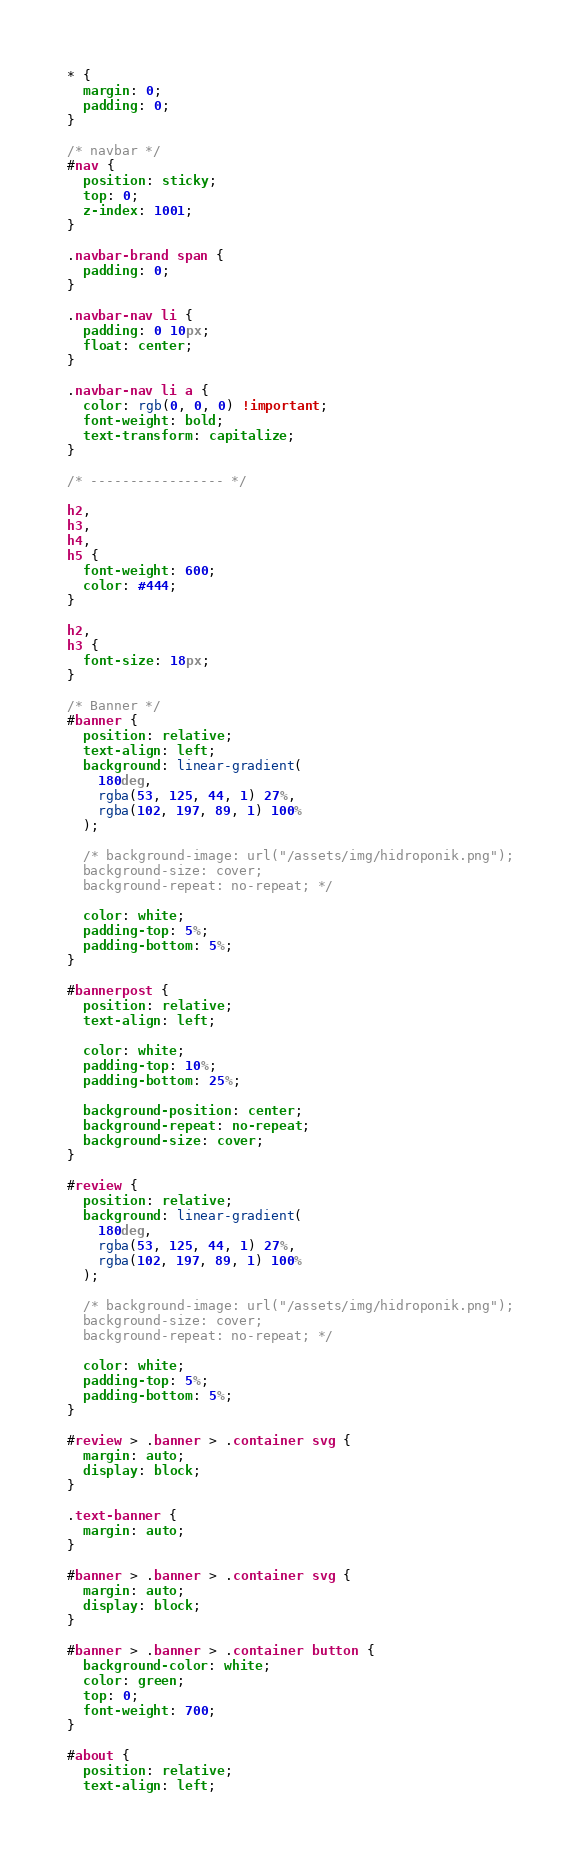<code> <loc_0><loc_0><loc_500><loc_500><_CSS_>* {
  margin: 0;
  padding: 0;
}

/* navbar */
#nav {
  position: sticky;
  top: 0;
  z-index: 1001;
}

.navbar-brand span {
  padding: 0;
}

.navbar-nav li {
  padding: 0 10px;
  float: center;
}

.navbar-nav li a {
  color: rgb(0, 0, 0) !important;
  font-weight: bold;
  text-transform: capitalize;
}

/* ----------------- */

h2,
h3,
h4,
h5 {
  font-weight: 600;
  color: #444;
}

h2,
h3 {
  font-size: 18px;
}

/* Banner */
#banner {
  position: relative;
  text-align: left;
  background: linear-gradient(
    180deg,
    rgba(53, 125, 44, 1) 27%,
    rgba(102, 197, 89, 1) 100%
  );

  /* background-image: url("/assets/img/hidroponik.png");
  background-size: cover;
  background-repeat: no-repeat; */

  color: white;
  padding-top: 5%;
  padding-bottom: 5%;
}

#bannerpost {
  position: relative;
  text-align: left;

  color: white;
  padding-top: 10%;
  padding-bottom: 25%;

  background-position: center;
  background-repeat: no-repeat;
  background-size: cover;
}

#review {
  position: relative;
  background: linear-gradient(
    180deg,
    rgba(53, 125, 44, 1) 27%,
    rgba(102, 197, 89, 1) 100%
  );

  /* background-image: url("/assets/img/hidroponik.png");
  background-size: cover;
  background-repeat: no-repeat; */

  color: white;
  padding-top: 5%;
  padding-bottom: 5%;
}

#review > .banner > .container svg {
  margin: auto;
  display: block;
}

.text-banner {
  margin: auto;
}

#banner > .banner > .container svg {
  margin: auto;
  display: block;
}

#banner > .banner > .container button {
  background-color: white;
  color: green;
  top: 0;
  font-weight: 700;
}

#about {
  position: relative;
  text-align: left;</code> 